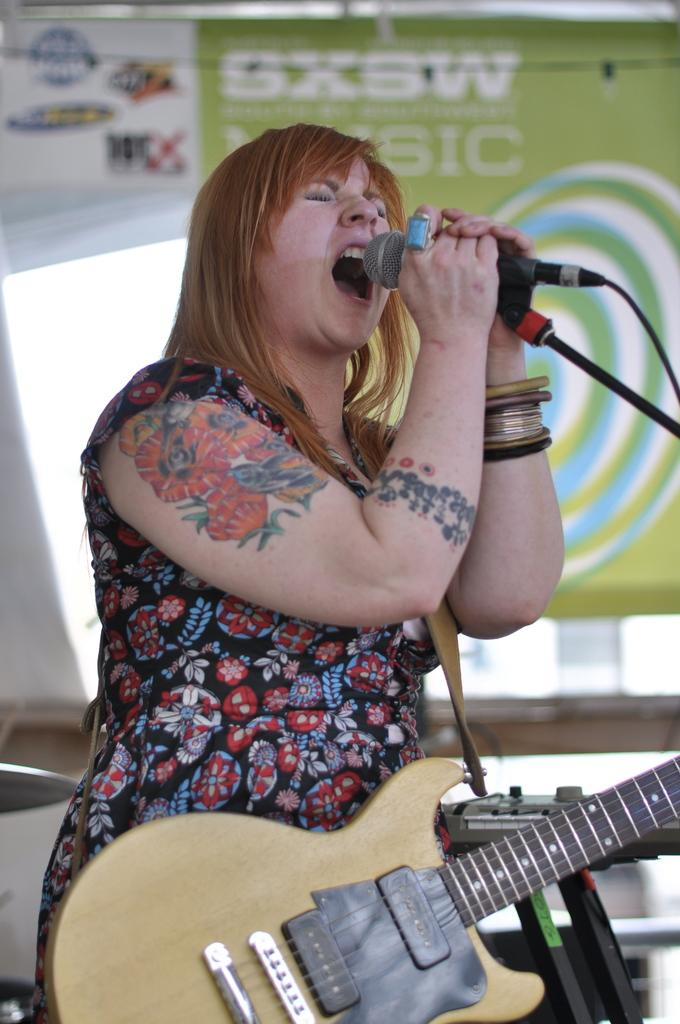What is the main subject of the image? There is a person in the center of the image. What is the person holding in the image? The person is holding a guitar and a microphone. What is the person doing in the image? The person is singing. What can be seen in the background of the image? There is a banner and a wall visible in the background. How many lizards can be seen crawling on the wall in the image? There are no lizards visible in the image; the wall is part of the background and does not have any lizards on it. What type of food is the person eating while singing in the image? There is no food present in the image; the person is holding a guitar and a microphone while singing. 